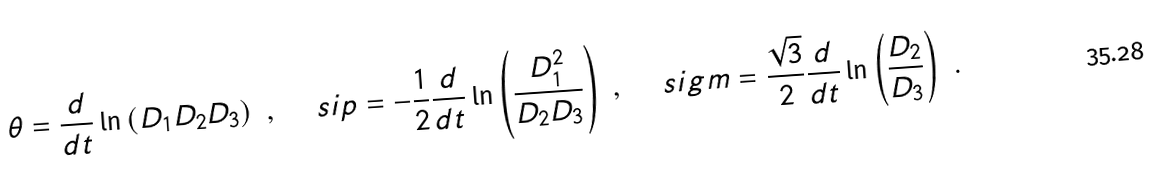<formula> <loc_0><loc_0><loc_500><loc_500>\theta = \frac { d } { d t } \ln \left ( D _ { 1 } D _ { 2 } D _ { 3 } \right ) \ , \quad \ s i p = - \frac { 1 } { 2 } \frac { d } { d t } \ln \left ( \frac { D _ { 1 } ^ { 2 } } { D _ { 2 } D _ { 3 } } \right ) \ , \quad \ s i g m = \frac { \sqrt { 3 } } { 2 } \frac { d } { d t } \ln \left ( \frac { D _ { 2 } } { D _ { 3 } } \right ) \ .</formula> 